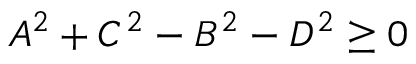Convert formula to latex. <formula><loc_0><loc_0><loc_500><loc_500>A ^ { 2 } + C ^ { 2 } - B ^ { 2 } - D ^ { 2 } \geq 0</formula> 